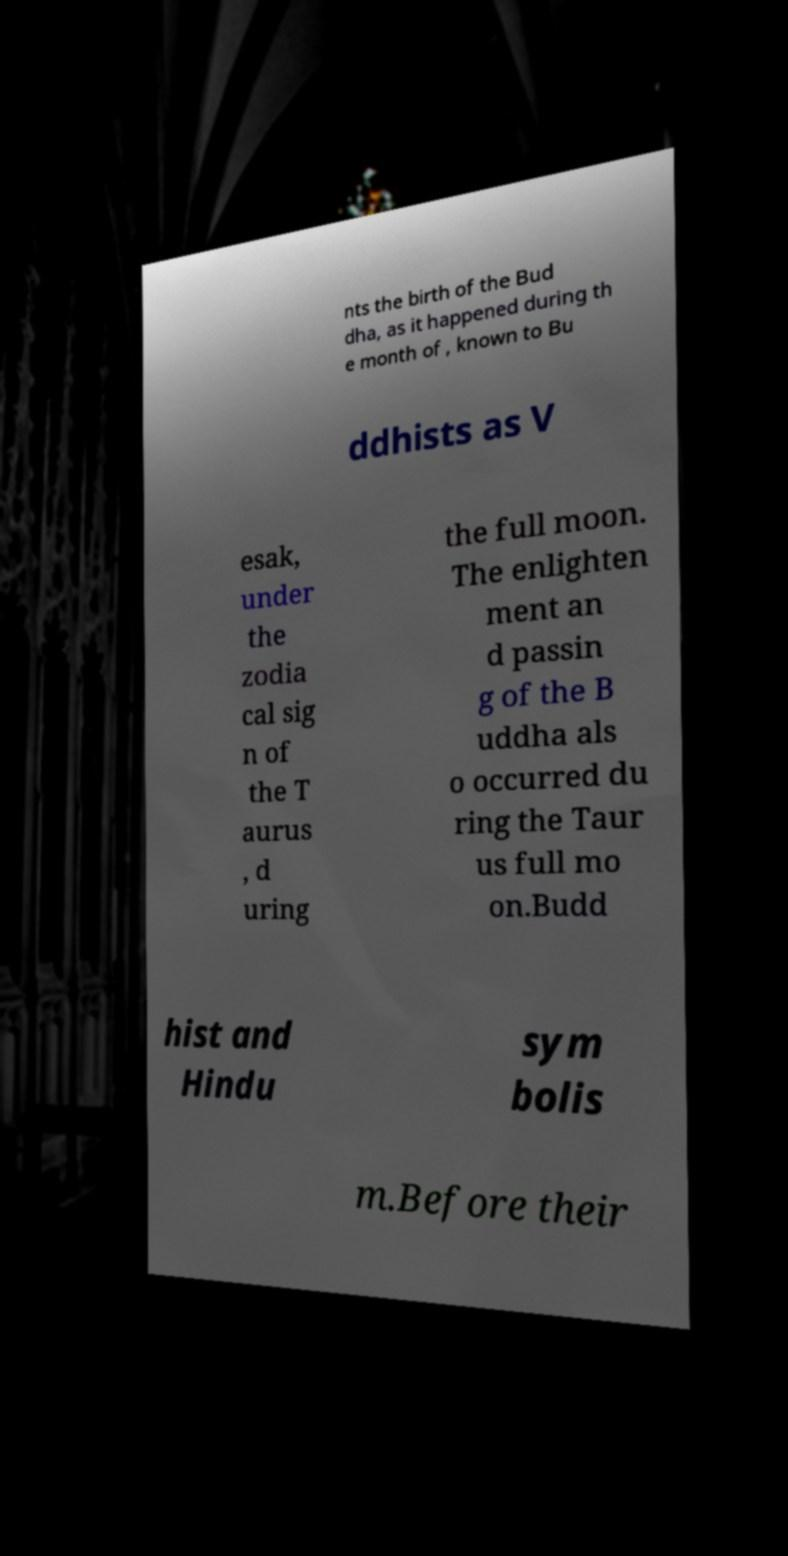I need the written content from this picture converted into text. Can you do that? nts the birth of the Bud dha, as it happened during th e month of , known to Bu ddhists as V esak, under the zodia cal sig n of the T aurus , d uring the full moon. The enlighten ment an d passin g of the B uddha als o occurred du ring the Taur us full mo on.Budd hist and Hindu sym bolis m.Before their 